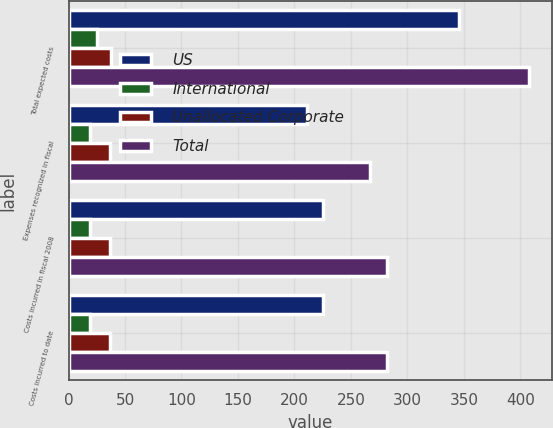Convert chart to OTSL. <chart><loc_0><loc_0><loc_500><loc_500><stacked_bar_chart><ecel><fcel>Total expected costs<fcel>Expenses recognized in fiscal<fcel>Costs incurred in fiscal 2008<fcel>Costs incurred to date<nl><fcel>US<fcel>345.3<fcel>210.9<fcel>225.7<fcel>225.7<nl><fcel>International<fcel>25.1<fcel>19.2<fcel>19.2<fcel>19.2<nl><fcel>Unallocated Corporate<fcel>37.4<fcel>36.8<fcel>36.8<fcel>36.8<nl><fcel>Total<fcel>407.8<fcel>266.9<fcel>281.7<fcel>281.7<nl></chart> 